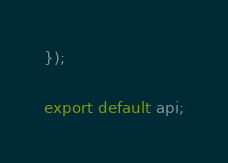Convert code to text. <code><loc_0><loc_0><loc_500><loc_500><_JavaScript_>});

export default api;
</code> 